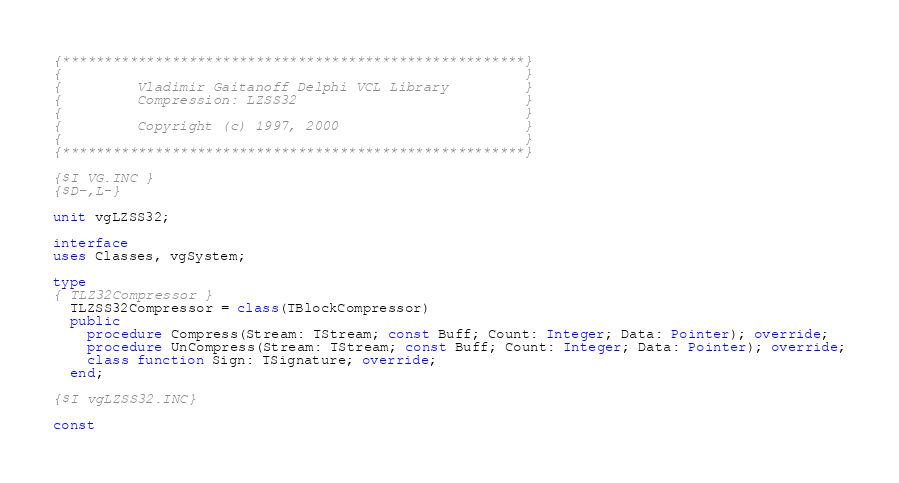Convert code to text. <code><loc_0><loc_0><loc_500><loc_500><_Pascal_>{*******************************************************}
{                                                       }
{         Vladimir Gaitanoff Delphi VCL Library         }
{         Compression: LZSS32                           }
{                                                       }
{         Copyright (c) 1997, 2000                      }
{                                                       }
{*******************************************************}

{$I VG.INC }
{$D-,L-}

unit vgLZSS32;

interface
uses Classes, vgSystem;

type
{ TLZ32Compressor }
  TLZSS32Compressor = class(TBlockCompressor)
  public
    procedure Compress(Stream: TStream; const Buff; Count: Integer; Data: Pointer); override;
    procedure UnCompress(Stream: TStream; const Buff; Count: Integer; Data: Pointer); override;
    class function Sign: TSignature; override;
  end;

{$I vgLZSS32.INC}

const</code> 